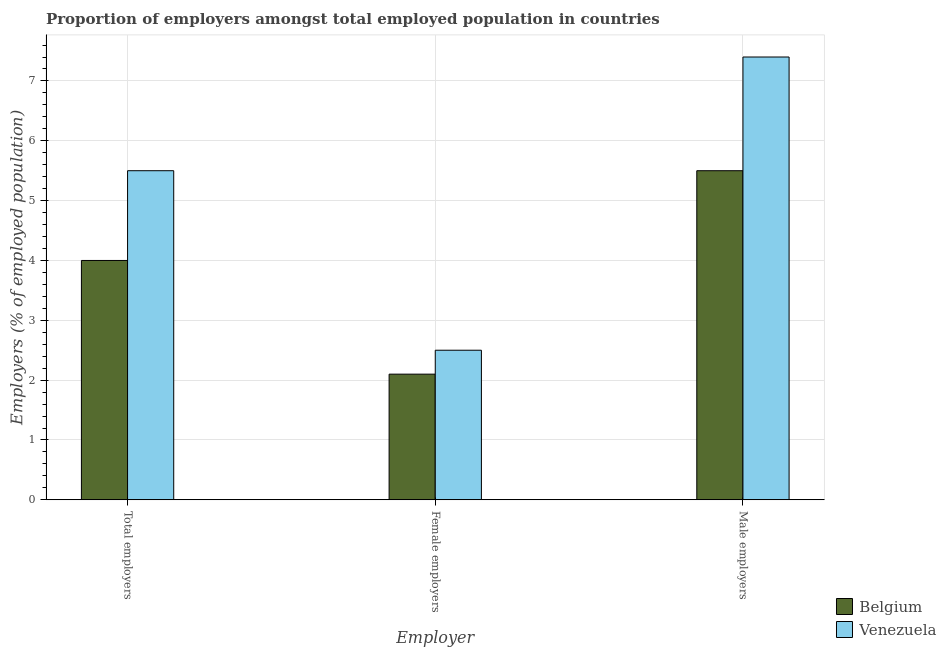How many groups of bars are there?
Offer a very short reply. 3. Are the number of bars per tick equal to the number of legend labels?
Your answer should be very brief. Yes. What is the label of the 3rd group of bars from the left?
Give a very brief answer. Male employers. In which country was the percentage of male employers maximum?
Provide a short and direct response. Venezuela. In which country was the percentage of total employers minimum?
Offer a terse response. Belgium. What is the total percentage of female employers in the graph?
Provide a short and direct response. 4.6. What is the difference between the percentage of male employers in Venezuela and that in Belgium?
Ensure brevity in your answer.  1.9. What is the difference between the percentage of female employers in Belgium and the percentage of total employers in Venezuela?
Give a very brief answer. -3.4. What is the average percentage of total employers per country?
Give a very brief answer. 4.75. What is the difference between the percentage of female employers and percentage of male employers in Belgium?
Give a very brief answer. -3.4. In how many countries, is the percentage of male employers greater than 0.6000000000000001 %?
Ensure brevity in your answer.  2. What is the ratio of the percentage of total employers in Venezuela to that in Belgium?
Give a very brief answer. 1.38. Is the difference between the percentage of female employers in Venezuela and Belgium greater than the difference between the percentage of total employers in Venezuela and Belgium?
Give a very brief answer. No. What is the difference between the highest and the second highest percentage of total employers?
Provide a short and direct response. 1.5. What is the difference between the highest and the lowest percentage of total employers?
Provide a succinct answer. 1.5. In how many countries, is the percentage of male employers greater than the average percentage of male employers taken over all countries?
Your response must be concise. 1. Is the sum of the percentage of total employers in Belgium and Venezuela greater than the maximum percentage of female employers across all countries?
Your answer should be very brief. Yes. What does the 2nd bar from the left in Male employers represents?
Keep it short and to the point. Venezuela. What does the 1st bar from the right in Male employers represents?
Your answer should be very brief. Venezuela. Is it the case that in every country, the sum of the percentage of total employers and percentage of female employers is greater than the percentage of male employers?
Your answer should be compact. Yes. How many bars are there?
Provide a succinct answer. 6. What is the difference between two consecutive major ticks on the Y-axis?
Keep it short and to the point. 1. Are the values on the major ticks of Y-axis written in scientific E-notation?
Your answer should be very brief. No. Does the graph contain any zero values?
Your answer should be very brief. No. Does the graph contain grids?
Offer a very short reply. Yes. Where does the legend appear in the graph?
Your answer should be compact. Bottom right. How are the legend labels stacked?
Keep it short and to the point. Vertical. What is the title of the graph?
Provide a short and direct response. Proportion of employers amongst total employed population in countries. What is the label or title of the X-axis?
Your answer should be very brief. Employer. What is the label or title of the Y-axis?
Provide a short and direct response. Employers (% of employed population). What is the Employers (% of employed population) of Belgium in Total employers?
Offer a terse response. 4. What is the Employers (% of employed population) of Belgium in Female employers?
Your answer should be very brief. 2.1. What is the Employers (% of employed population) of Venezuela in Male employers?
Give a very brief answer. 7.4. Across all Employer, what is the maximum Employers (% of employed population) in Venezuela?
Give a very brief answer. 7.4. Across all Employer, what is the minimum Employers (% of employed population) of Belgium?
Ensure brevity in your answer.  2.1. Across all Employer, what is the minimum Employers (% of employed population) in Venezuela?
Make the answer very short. 2.5. What is the difference between the Employers (% of employed population) in Belgium in Total employers and that in Female employers?
Give a very brief answer. 1.9. What is the difference between the Employers (% of employed population) of Belgium in Total employers and that in Male employers?
Keep it short and to the point. -1.5. What is the difference between the Employers (% of employed population) of Belgium in Female employers and that in Male employers?
Make the answer very short. -3.4. What is the difference between the Employers (% of employed population) of Belgium in Total employers and the Employers (% of employed population) of Venezuela in Male employers?
Keep it short and to the point. -3.4. What is the average Employers (% of employed population) of Belgium per Employer?
Give a very brief answer. 3.87. What is the average Employers (% of employed population) of Venezuela per Employer?
Offer a very short reply. 5.13. What is the ratio of the Employers (% of employed population) in Belgium in Total employers to that in Female employers?
Offer a terse response. 1.9. What is the ratio of the Employers (% of employed population) of Venezuela in Total employers to that in Female employers?
Make the answer very short. 2.2. What is the ratio of the Employers (% of employed population) of Belgium in Total employers to that in Male employers?
Provide a succinct answer. 0.73. What is the ratio of the Employers (% of employed population) of Venezuela in Total employers to that in Male employers?
Your answer should be very brief. 0.74. What is the ratio of the Employers (% of employed population) in Belgium in Female employers to that in Male employers?
Your response must be concise. 0.38. What is the ratio of the Employers (% of employed population) of Venezuela in Female employers to that in Male employers?
Make the answer very short. 0.34. What is the difference between the highest and the lowest Employers (% of employed population) of Belgium?
Make the answer very short. 3.4. What is the difference between the highest and the lowest Employers (% of employed population) in Venezuela?
Keep it short and to the point. 4.9. 